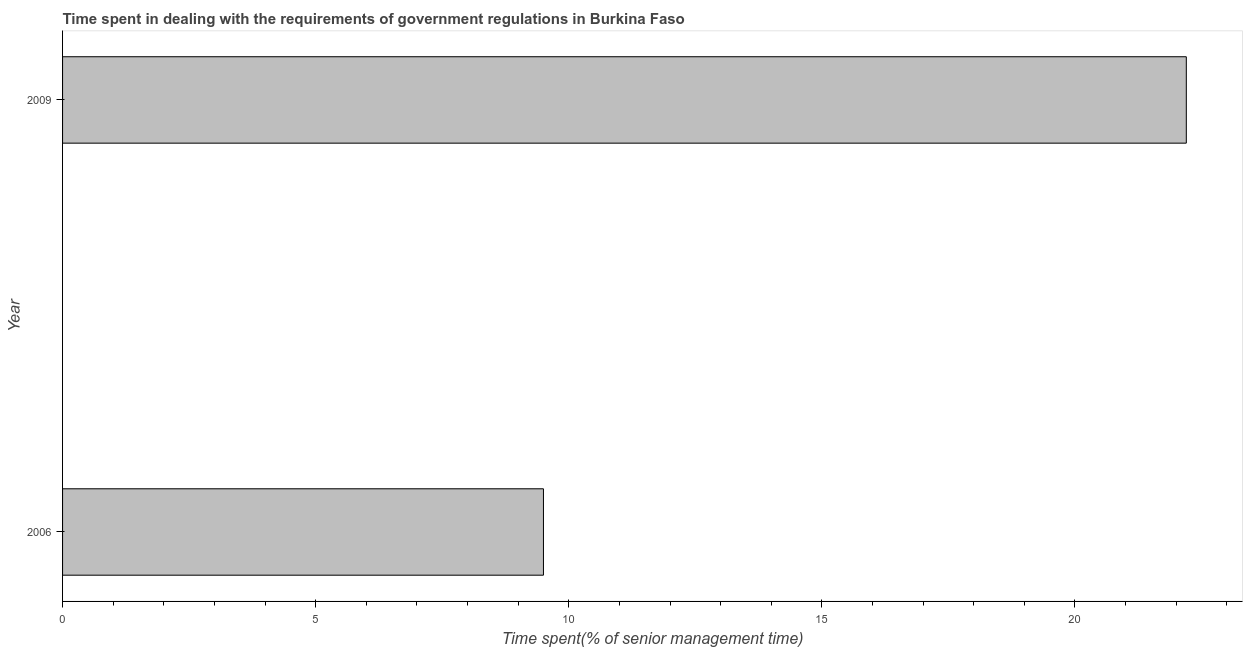Does the graph contain any zero values?
Your answer should be very brief. No. Does the graph contain grids?
Make the answer very short. No. What is the title of the graph?
Offer a terse response. Time spent in dealing with the requirements of government regulations in Burkina Faso. What is the label or title of the X-axis?
Your answer should be very brief. Time spent(% of senior management time). What is the label or title of the Y-axis?
Provide a short and direct response. Year. Across all years, what is the maximum time spent in dealing with government regulations?
Keep it short and to the point. 22.2. Across all years, what is the minimum time spent in dealing with government regulations?
Make the answer very short. 9.5. In which year was the time spent in dealing with government regulations minimum?
Your response must be concise. 2006. What is the sum of the time spent in dealing with government regulations?
Provide a succinct answer. 31.7. What is the average time spent in dealing with government regulations per year?
Your response must be concise. 15.85. What is the median time spent in dealing with government regulations?
Offer a very short reply. 15.85. Do a majority of the years between 2009 and 2006 (inclusive) have time spent in dealing with government regulations greater than 2 %?
Make the answer very short. No. What is the ratio of the time spent in dealing with government regulations in 2006 to that in 2009?
Ensure brevity in your answer.  0.43. Is the time spent in dealing with government regulations in 2006 less than that in 2009?
Give a very brief answer. Yes. How many bars are there?
Provide a succinct answer. 2. How many years are there in the graph?
Make the answer very short. 2. What is the difference between two consecutive major ticks on the X-axis?
Keep it short and to the point. 5. Are the values on the major ticks of X-axis written in scientific E-notation?
Provide a short and direct response. No. What is the Time spent(% of senior management time) in 2006?
Your answer should be very brief. 9.5. What is the Time spent(% of senior management time) in 2009?
Provide a succinct answer. 22.2. What is the difference between the Time spent(% of senior management time) in 2006 and 2009?
Provide a succinct answer. -12.7. What is the ratio of the Time spent(% of senior management time) in 2006 to that in 2009?
Your answer should be compact. 0.43. 